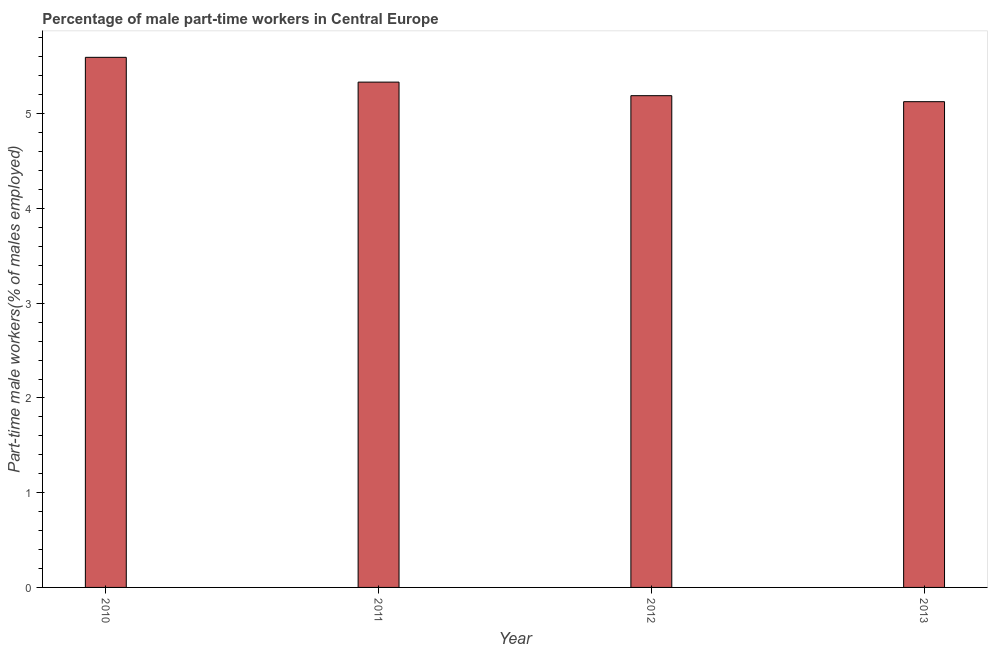Does the graph contain grids?
Your answer should be very brief. No. What is the title of the graph?
Provide a succinct answer. Percentage of male part-time workers in Central Europe. What is the label or title of the Y-axis?
Provide a short and direct response. Part-time male workers(% of males employed). What is the percentage of part-time male workers in 2011?
Provide a short and direct response. 5.33. Across all years, what is the maximum percentage of part-time male workers?
Give a very brief answer. 5.6. Across all years, what is the minimum percentage of part-time male workers?
Your answer should be very brief. 5.13. In which year was the percentage of part-time male workers minimum?
Give a very brief answer. 2013. What is the sum of the percentage of part-time male workers?
Your answer should be very brief. 21.25. What is the difference between the percentage of part-time male workers in 2010 and 2012?
Offer a terse response. 0.41. What is the average percentage of part-time male workers per year?
Your answer should be compact. 5.31. What is the median percentage of part-time male workers?
Ensure brevity in your answer.  5.26. Do a majority of the years between 2010 and 2012 (inclusive) have percentage of part-time male workers greater than 4.4 %?
Your answer should be very brief. Yes. Is the difference between the percentage of part-time male workers in 2010 and 2012 greater than the difference between any two years?
Give a very brief answer. No. What is the difference between the highest and the second highest percentage of part-time male workers?
Give a very brief answer. 0.26. What is the difference between the highest and the lowest percentage of part-time male workers?
Your answer should be compact. 0.47. Are all the bars in the graph horizontal?
Provide a short and direct response. No. Are the values on the major ticks of Y-axis written in scientific E-notation?
Provide a succinct answer. No. What is the Part-time male workers(% of males employed) in 2010?
Offer a terse response. 5.6. What is the Part-time male workers(% of males employed) of 2011?
Provide a short and direct response. 5.33. What is the Part-time male workers(% of males employed) of 2012?
Your response must be concise. 5.19. What is the Part-time male workers(% of males employed) of 2013?
Make the answer very short. 5.13. What is the difference between the Part-time male workers(% of males employed) in 2010 and 2011?
Provide a short and direct response. 0.26. What is the difference between the Part-time male workers(% of males employed) in 2010 and 2012?
Give a very brief answer. 0.4. What is the difference between the Part-time male workers(% of males employed) in 2010 and 2013?
Ensure brevity in your answer.  0.47. What is the difference between the Part-time male workers(% of males employed) in 2011 and 2012?
Keep it short and to the point. 0.14. What is the difference between the Part-time male workers(% of males employed) in 2011 and 2013?
Your answer should be very brief. 0.21. What is the difference between the Part-time male workers(% of males employed) in 2012 and 2013?
Ensure brevity in your answer.  0.06. What is the ratio of the Part-time male workers(% of males employed) in 2010 to that in 2011?
Give a very brief answer. 1.05. What is the ratio of the Part-time male workers(% of males employed) in 2010 to that in 2012?
Provide a short and direct response. 1.08. What is the ratio of the Part-time male workers(% of males employed) in 2010 to that in 2013?
Keep it short and to the point. 1.09. What is the ratio of the Part-time male workers(% of males employed) in 2011 to that in 2012?
Keep it short and to the point. 1.03. What is the ratio of the Part-time male workers(% of males employed) in 2012 to that in 2013?
Provide a short and direct response. 1.01. 